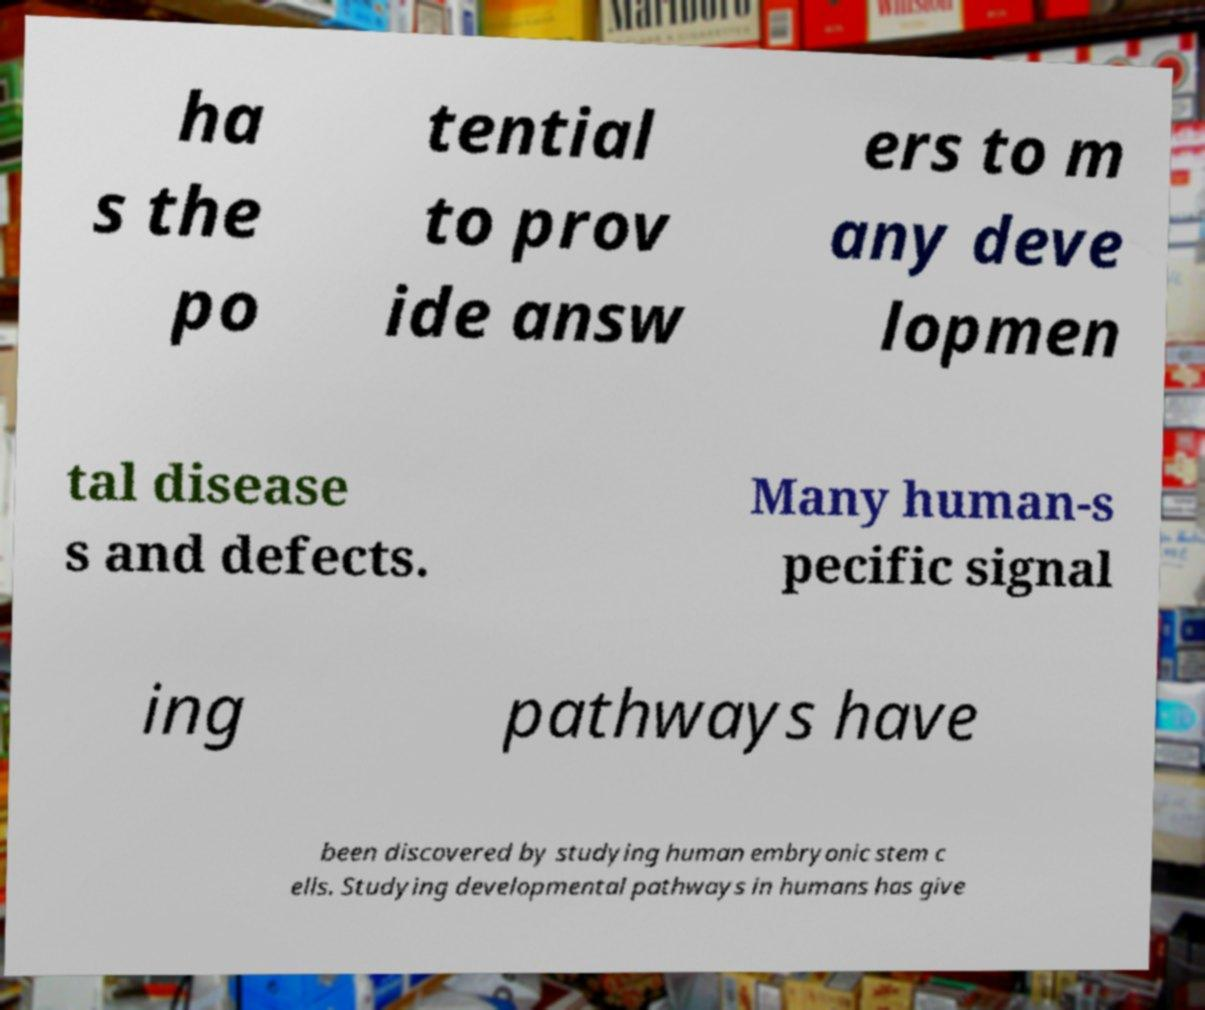Please read and relay the text visible in this image. What does it say? ha s the po tential to prov ide answ ers to m any deve lopmen tal disease s and defects. Many human-s pecific signal ing pathways have been discovered by studying human embryonic stem c ells. Studying developmental pathways in humans has give 